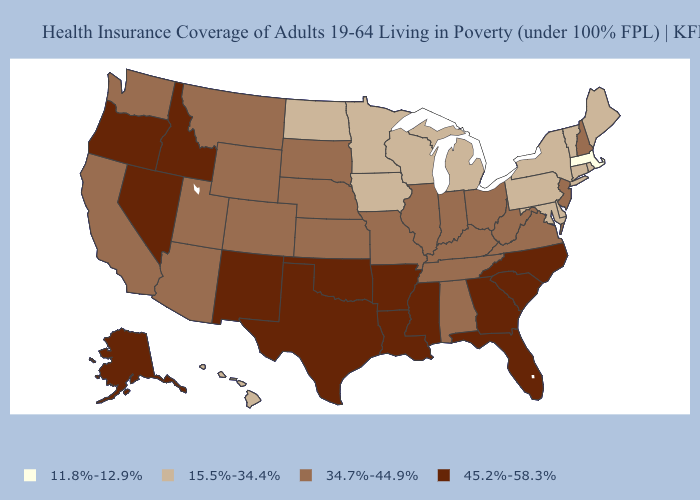Among the states that border North Carolina , does Tennessee have the highest value?
Keep it brief. No. Name the states that have a value in the range 45.2%-58.3%?
Quick response, please. Alaska, Arkansas, Florida, Georgia, Idaho, Louisiana, Mississippi, Nevada, New Mexico, North Carolina, Oklahoma, Oregon, South Carolina, Texas. How many symbols are there in the legend?
Short answer required. 4. How many symbols are there in the legend?
Give a very brief answer. 4. What is the lowest value in the Northeast?
Keep it brief. 11.8%-12.9%. What is the value of Kentucky?
Be succinct. 34.7%-44.9%. What is the value of Oregon?
Write a very short answer. 45.2%-58.3%. What is the highest value in the USA?
Be succinct. 45.2%-58.3%. Name the states that have a value in the range 11.8%-12.9%?
Quick response, please. Massachusetts. Does the first symbol in the legend represent the smallest category?
Be succinct. Yes. Name the states that have a value in the range 11.8%-12.9%?
Write a very short answer. Massachusetts. Name the states that have a value in the range 45.2%-58.3%?
Short answer required. Alaska, Arkansas, Florida, Georgia, Idaho, Louisiana, Mississippi, Nevada, New Mexico, North Carolina, Oklahoma, Oregon, South Carolina, Texas. What is the value of Missouri?
Keep it brief. 34.7%-44.9%. Name the states that have a value in the range 45.2%-58.3%?
Give a very brief answer. Alaska, Arkansas, Florida, Georgia, Idaho, Louisiana, Mississippi, Nevada, New Mexico, North Carolina, Oklahoma, Oregon, South Carolina, Texas. Name the states that have a value in the range 34.7%-44.9%?
Quick response, please. Alabama, Arizona, California, Colorado, Illinois, Indiana, Kansas, Kentucky, Missouri, Montana, Nebraska, New Hampshire, New Jersey, Ohio, South Dakota, Tennessee, Utah, Virginia, Washington, West Virginia, Wyoming. 